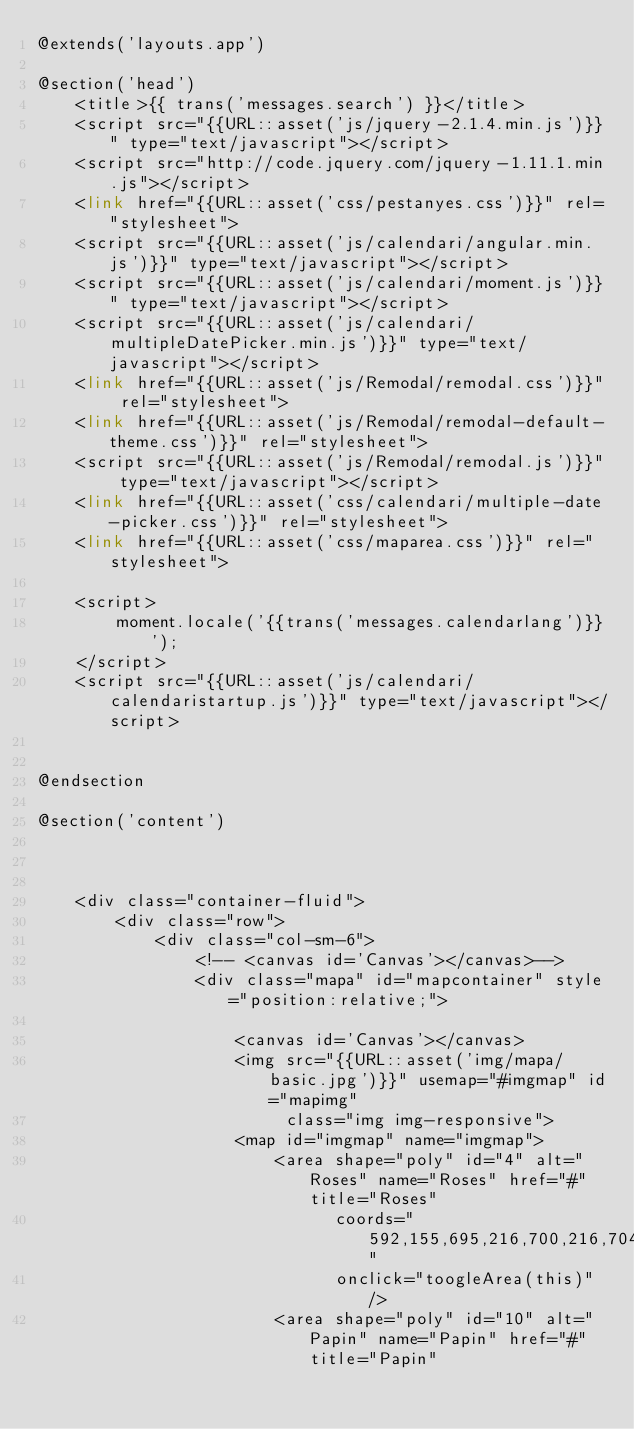Convert code to text. <code><loc_0><loc_0><loc_500><loc_500><_PHP_>@extends('layouts.app')

@section('head')
    <title>{{ trans('messages.search') }}</title>
    <script src="{{URL::asset('js/jquery-2.1.4.min.js')}}" type="text/javascript"></script>
    <script src="http://code.jquery.com/jquery-1.11.1.min.js"></script>
    <link href="{{URL::asset('css/pestanyes.css')}}" rel="stylesheet">
    <script src="{{URL::asset('js/calendari/angular.min.js')}}" type="text/javascript"></script>
    <script src="{{URL::asset('js/calendari/moment.js')}}" type="text/javascript"></script>
    <script src="{{URL::asset('js/calendari/multipleDatePicker.min.js')}}" type="text/javascript"></script>
    <link href="{{URL::asset('js/Remodal/remodal.css')}}" rel="stylesheet">
    <link href="{{URL::asset('js/Remodal/remodal-default-theme.css')}}" rel="stylesheet">
    <script src="{{URL::asset('js/Remodal/remodal.js')}}" type="text/javascript"></script>
    <link href="{{URL::asset('css/calendari/multiple-date-picker.css')}}" rel="stylesheet">
    <link href="{{URL::asset('css/maparea.css')}}" rel="stylesheet">

    <script>
        moment.locale('{{trans('messages.calendarlang')}}');
    </script>
    <script src="{{URL::asset('js/calendari/calendaristartup.js')}}" type="text/javascript"></script>


@endsection

@section('content')



    <div class="container-fluid">
        <div class="row">
            <div class="col-sm-6">
                <!-- <canvas id='Canvas'></canvas>-->
                <div class="mapa" id="mapcontainer" style="position:relative;">

                    <canvas id='Canvas'></canvas>
                    <img src="{{URL::asset('img/mapa/basic.jpg')}}" usemap="#imgmap" id="mapimg"
                         class="img img-responsive">
                    <map id="imgmap" name="imgmap">
                        <area shape="poly" id="4" alt="Roses" name="Roses" href="#" title="Roses"
                              coords="592,155,695,216,700,216,704,214,707,210,708,204,705,200,693,192,602,138,592,138,587,142,587,150,588,153,590,154"
                              onclick="toogleArea(this)"/>
                        <area shape="poly" id="10" alt="Papin" name="Papin" href="#" title="Papin"</code> 